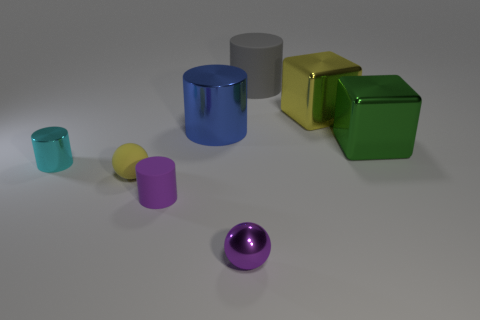Do the tiny rubber cylinder and the tiny metallic sphere have the same color?
Give a very brief answer. Yes. How big is the matte thing that is both to the right of the small matte sphere and to the left of the tiny purple metallic object?
Your answer should be compact. Small. What number of gray cylinders have the same material as the green thing?
Give a very brief answer. 0. The big cylinder that is the same material as the tiny yellow object is what color?
Your answer should be very brief. Gray. Do the cube behind the large blue cylinder and the small matte sphere have the same color?
Provide a short and direct response. Yes. What is the yellow object that is behind the small cyan cylinder made of?
Your response must be concise. Metal. Are there an equal number of cyan objects to the right of the shiny ball and big metallic cylinders?
Ensure brevity in your answer.  No. What number of cubes are the same color as the big metallic cylinder?
Make the answer very short. 0. There is a tiny shiny object that is the same shape as the gray matte object; what is its color?
Give a very brief answer. Cyan. Do the green metallic cube and the cyan object have the same size?
Give a very brief answer. No. 